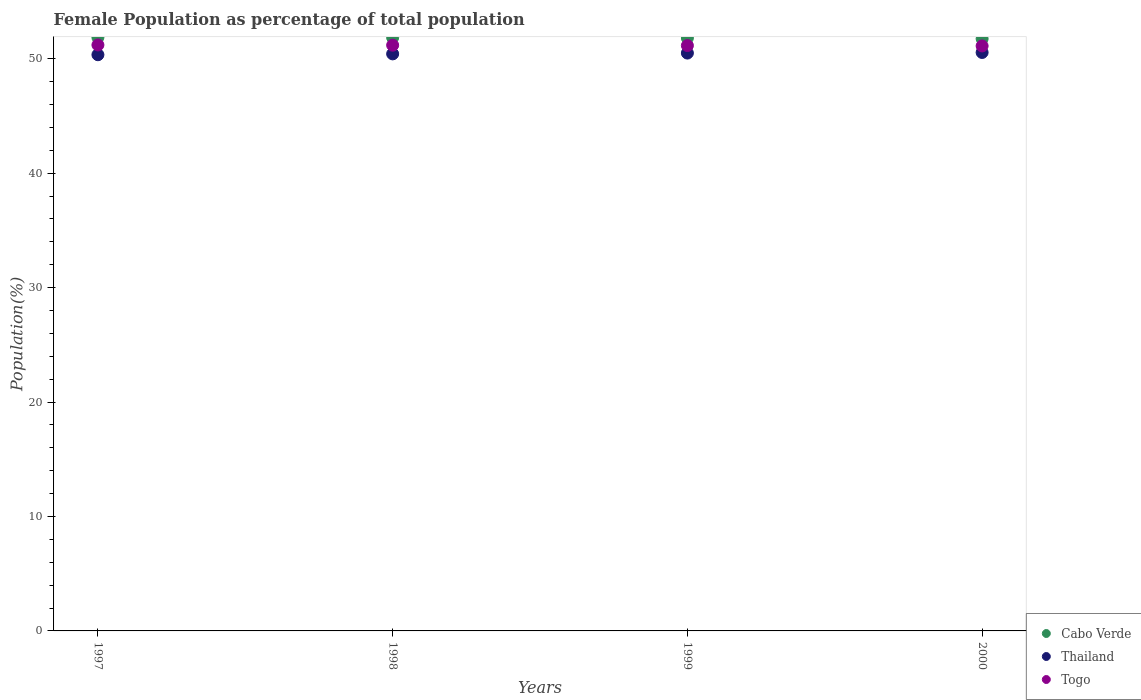How many different coloured dotlines are there?
Your answer should be very brief. 3. What is the female population in in Cabo Verde in 1998?
Keep it short and to the point. 51.84. Across all years, what is the maximum female population in in Thailand?
Provide a succinct answer. 50.55. Across all years, what is the minimum female population in in Thailand?
Your answer should be compact. 50.35. What is the total female population in in Cabo Verde in the graph?
Offer a terse response. 207.26. What is the difference between the female population in in Togo in 1997 and that in 2000?
Keep it short and to the point. 0.09. What is the difference between the female population in in Cabo Verde in 1998 and the female population in in Thailand in 1997?
Your answer should be very brief. 1.5. What is the average female population in in Togo per year?
Keep it short and to the point. 51.16. In the year 1997, what is the difference between the female population in in Togo and female population in in Cabo Verde?
Provide a succinct answer. -0.66. In how many years, is the female population in in Cabo Verde greater than 24 %?
Offer a very short reply. 4. What is the ratio of the female population in in Thailand in 1998 to that in 2000?
Provide a succinct answer. 1. Is the female population in in Thailand in 1998 less than that in 2000?
Ensure brevity in your answer.  Yes. Is the difference between the female population in in Togo in 1998 and 1999 greater than the difference between the female population in in Cabo Verde in 1998 and 1999?
Provide a short and direct response. No. What is the difference between the highest and the second highest female population in in Togo?
Make the answer very short. 0.02. What is the difference between the highest and the lowest female population in in Thailand?
Offer a terse response. 0.2. In how many years, is the female population in in Thailand greater than the average female population in in Thailand taken over all years?
Give a very brief answer. 2. Is it the case that in every year, the sum of the female population in in Togo and female population in in Thailand  is greater than the female population in in Cabo Verde?
Offer a terse response. Yes. Is the female population in in Togo strictly greater than the female population in in Cabo Verde over the years?
Your response must be concise. No. How many years are there in the graph?
Provide a succinct answer. 4. What is the difference between two consecutive major ticks on the Y-axis?
Give a very brief answer. 10. Are the values on the major ticks of Y-axis written in scientific E-notation?
Offer a terse response. No. Does the graph contain any zero values?
Provide a succinct answer. No. Does the graph contain grids?
Provide a short and direct response. No. What is the title of the graph?
Provide a short and direct response. Female Population as percentage of total population. What is the label or title of the X-axis?
Your answer should be compact. Years. What is the label or title of the Y-axis?
Offer a terse response. Population(%). What is the Population(%) of Cabo Verde in 1997?
Ensure brevity in your answer.  51.86. What is the Population(%) of Thailand in 1997?
Provide a succinct answer. 50.35. What is the Population(%) of Togo in 1997?
Make the answer very short. 51.2. What is the Population(%) in Cabo Verde in 1998?
Provide a succinct answer. 51.84. What is the Population(%) of Thailand in 1998?
Your response must be concise. 50.42. What is the Population(%) in Togo in 1998?
Your response must be concise. 51.18. What is the Population(%) in Cabo Verde in 1999?
Provide a succinct answer. 51.81. What is the Population(%) in Thailand in 1999?
Offer a terse response. 50.49. What is the Population(%) in Togo in 1999?
Ensure brevity in your answer.  51.15. What is the Population(%) in Cabo Verde in 2000?
Offer a terse response. 51.74. What is the Population(%) in Thailand in 2000?
Your answer should be very brief. 50.55. What is the Population(%) of Togo in 2000?
Keep it short and to the point. 51.12. Across all years, what is the maximum Population(%) in Cabo Verde?
Make the answer very short. 51.86. Across all years, what is the maximum Population(%) of Thailand?
Your response must be concise. 50.55. Across all years, what is the maximum Population(%) in Togo?
Offer a very short reply. 51.2. Across all years, what is the minimum Population(%) in Cabo Verde?
Provide a short and direct response. 51.74. Across all years, what is the minimum Population(%) of Thailand?
Provide a short and direct response. 50.35. Across all years, what is the minimum Population(%) of Togo?
Ensure brevity in your answer.  51.12. What is the total Population(%) in Cabo Verde in the graph?
Your response must be concise. 207.26. What is the total Population(%) of Thailand in the graph?
Offer a terse response. 201.81. What is the total Population(%) of Togo in the graph?
Your response must be concise. 204.65. What is the difference between the Population(%) of Cabo Verde in 1997 and that in 1998?
Offer a very short reply. 0.01. What is the difference between the Population(%) in Thailand in 1997 and that in 1998?
Your response must be concise. -0.07. What is the difference between the Population(%) of Togo in 1997 and that in 1998?
Your answer should be very brief. 0.02. What is the difference between the Population(%) in Cabo Verde in 1997 and that in 1999?
Your answer should be very brief. 0.05. What is the difference between the Population(%) in Thailand in 1997 and that in 1999?
Your answer should be compact. -0.14. What is the difference between the Population(%) in Togo in 1997 and that in 1999?
Ensure brevity in your answer.  0.05. What is the difference between the Population(%) in Cabo Verde in 1997 and that in 2000?
Your response must be concise. 0.12. What is the difference between the Population(%) of Thailand in 1997 and that in 2000?
Give a very brief answer. -0.2. What is the difference between the Population(%) in Togo in 1997 and that in 2000?
Keep it short and to the point. 0.09. What is the difference between the Population(%) in Cabo Verde in 1998 and that in 1999?
Ensure brevity in your answer.  0.03. What is the difference between the Population(%) in Thailand in 1998 and that in 1999?
Your answer should be compact. -0.07. What is the difference between the Population(%) of Togo in 1998 and that in 1999?
Give a very brief answer. 0.03. What is the difference between the Population(%) of Cabo Verde in 1998 and that in 2000?
Give a very brief answer. 0.1. What is the difference between the Population(%) in Thailand in 1998 and that in 2000?
Make the answer very short. -0.12. What is the difference between the Population(%) in Togo in 1998 and that in 2000?
Offer a very short reply. 0.06. What is the difference between the Population(%) of Cabo Verde in 1999 and that in 2000?
Ensure brevity in your answer.  0.07. What is the difference between the Population(%) of Thailand in 1999 and that in 2000?
Keep it short and to the point. -0.05. What is the difference between the Population(%) in Togo in 1999 and that in 2000?
Your answer should be very brief. 0.03. What is the difference between the Population(%) of Cabo Verde in 1997 and the Population(%) of Thailand in 1998?
Make the answer very short. 1.44. What is the difference between the Population(%) of Cabo Verde in 1997 and the Population(%) of Togo in 1998?
Your response must be concise. 0.68. What is the difference between the Population(%) in Thailand in 1997 and the Population(%) in Togo in 1998?
Your response must be concise. -0.83. What is the difference between the Population(%) of Cabo Verde in 1997 and the Population(%) of Thailand in 1999?
Ensure brevity in your answer.  1.37. What is the difference between the Population(%) in Cabo Verde in 1997 and the Population(%) in Togo in 1999?
Make the answer very short. 0.71. What is the difference between the Population(%) of Thailand in 1997 and the Population(%) of Togo in 1999?
Your response must be concise. -0.8. What is the difference between the Population(%) of Cabo Verde in 1997 and the Population(%) of Thailand in 2000?
Offer a terse response. 1.31. What is the difference between the Population(%) of Cabo Verde in 1997 and the Population(%) of Togo in 2000?
Keep it short and to the point. 0.74. What is the difference between the Population(%) in Thailand in 1997 and the Population(%) in Togo in 2000?
Provide a short and direct response. -0.77. What is the difference between the Population(%) in Cabo Verde in 1998 and the Population(%) in Thailand in 1999?
Provide a short and direct response. 1.35. What is the difference between the Population(%) in Cabo Verde in 1998 and the Population(%) in Togo in 1999?
Make the answer very short. 0.69. What is the difference between the Population(%) in Thailand in 1998 and the Population(%) in Togo in 1999?
Provide a short and direct response. -0.73. What is the difference between the Population(%) in Cabo Verde in 1998 and the Population(%) in Thailand in 2000?
Make the answer very short. 1.3. What is the difference between the Population(%) of Cabo Verde in 1998 and the Population(%) of Togo in 2000?
Provide a short and direct response. 0.73. What is the difference between the Population(%) of Thailand in 1998 and the Population(%) of Togo in 2000?
Offer a terse response. -0.69. What is the difference between the Population(%) of Cabo Verde in 1999 and the Population(%) of Thailand in 2000?
Keep it short and to the point. 1.27. What is the difference between the Population(%) of Cabo Verde in 1999 and the Population(%) of Togo in 2000?
Ensure brevity in your answer.  0.69. What is the difference between the Population(%) in Thailand in 1999 and the Population(%) in Togo in 2000?
Offer a terse response. -0.62. What is the average Population(%) of Cabo Verde per year?
Keep it short and to the point. 51.81. What is the average Population(%) in Thailand per year?
Provide a short and direct response. 50.45. What is the average Population(%) of Togo per year?
Offer a terse response. 51.16. In the year 1997, what is the difference between the Population(%) of Cabo Verde and Population(%) of Thailand?
Your response must be concise. 1.51. In the year 1997, what is the difference between the Population(%) of Cabo Verde and Population(%) of Togo?
Offer a very short reply. 0.66. In the year 1997, what is the difference between the Population(%) of Thailand and Population(%) of Togo?
Ensure brevity in your answer.  -0.85. In the year 1998, what is the difference between the Population(%) of Cabo Verde and Population(%) of Thailand?
Give a very brief answer. 1.42. In the year 1998, what is the difference between the Population(%) in Cabo Verde and Population(%) in Togo?
Ensure brevity in your answer.  0.66. In the year 1998, what is the difference between the Population(%) in Thailand and Population(%) in Togo?
Ensure brevity in your answer.  -0.76. In the year 1999, what is the difference between the Population(%) in Cabo Verde and Population(%) in Thailand?
Your answer should be very brief. 1.32. In the year 1999, what is the difference between the Population(%) of Cabo Verde and Population(%) of Togo?
Offer a very short reply. 0.66. In the year 1999, what is the difference between the Population(%) in Thailand and Population(%) in Togo?
Make the answer very short. -0.66. In the year 2000, what is the difference between the Population(%) in Cabo Verde and Population(%) in Thailand?
Offer a terse response. 1.2. In the year 2000, what is the difference between the Population(%) of Cabo Verde and Population(%) of Togo?
Your answer should be very brief. 0.63. In the year 2000, what is the difference between the Population(%) in Thailand and Population(%) in Togo?
Provide a short and direct response. -0.57. What is the ratio of the Population(%) of Thailand in 1997 to that in 1998?
Offer a very short reply. 1. What is the ratio of the Population(%) of Cabo Verde in 1997 to that in 1999?
Offer a very short reply. 1. What is the ratio of the Population(%) in Thailand in 1997 to that in 2000?
Provide a short and direct response. 1. What is the ratio of the Population(%) of Togo in 1997 to that in 2000?
Make the answer very short. 1. What is the ratio of the Population(%) of Cabo Verde in 1998 to that in 1999?
Offer a very short reply. 1. What is the ratio of the Population(%) in Togo in 1998 to that in 1999?
Your answer should be compact. 1. What is the ratio of the Population(%) of Thailand in 1998 to that in 2000?
Ensure brevity in your answer.  1. What is the ratio of the Population(%) in Togo in 1998 to that in 2000?
Your response must be concise. 1. What is the ratio of the Population(%) in Cabo Verde in 1999 to that in 2000?
Your answer should be compact. 1. What is the ratio of the Population(%) of Togo in 1999 to that in 2000?
Your answer should be very brief. 1. What is the difference between the highest and the second highest Population(%) of Cabo Verde?
Your answer should be compact. 0.01. What is the difference between the highest and the second highest Population(%) in Thailand?
Keep it short and to the point. 0.05. What is the difference between the highest and the second highest Population(%) of Togo?
Offer a very short reply. 0.02. What is the difference between the highest and the lowest Population(%) of Cabo Verde?
Your answer should be compact. 0.12. What is the difference between the highest and the lowest Population(%) in Thailand?
Keep it short and to the point. 0.2. What is the difference between the highest and the lowest Population(%) in Togo?
Your answer should be compact. 0.09. 